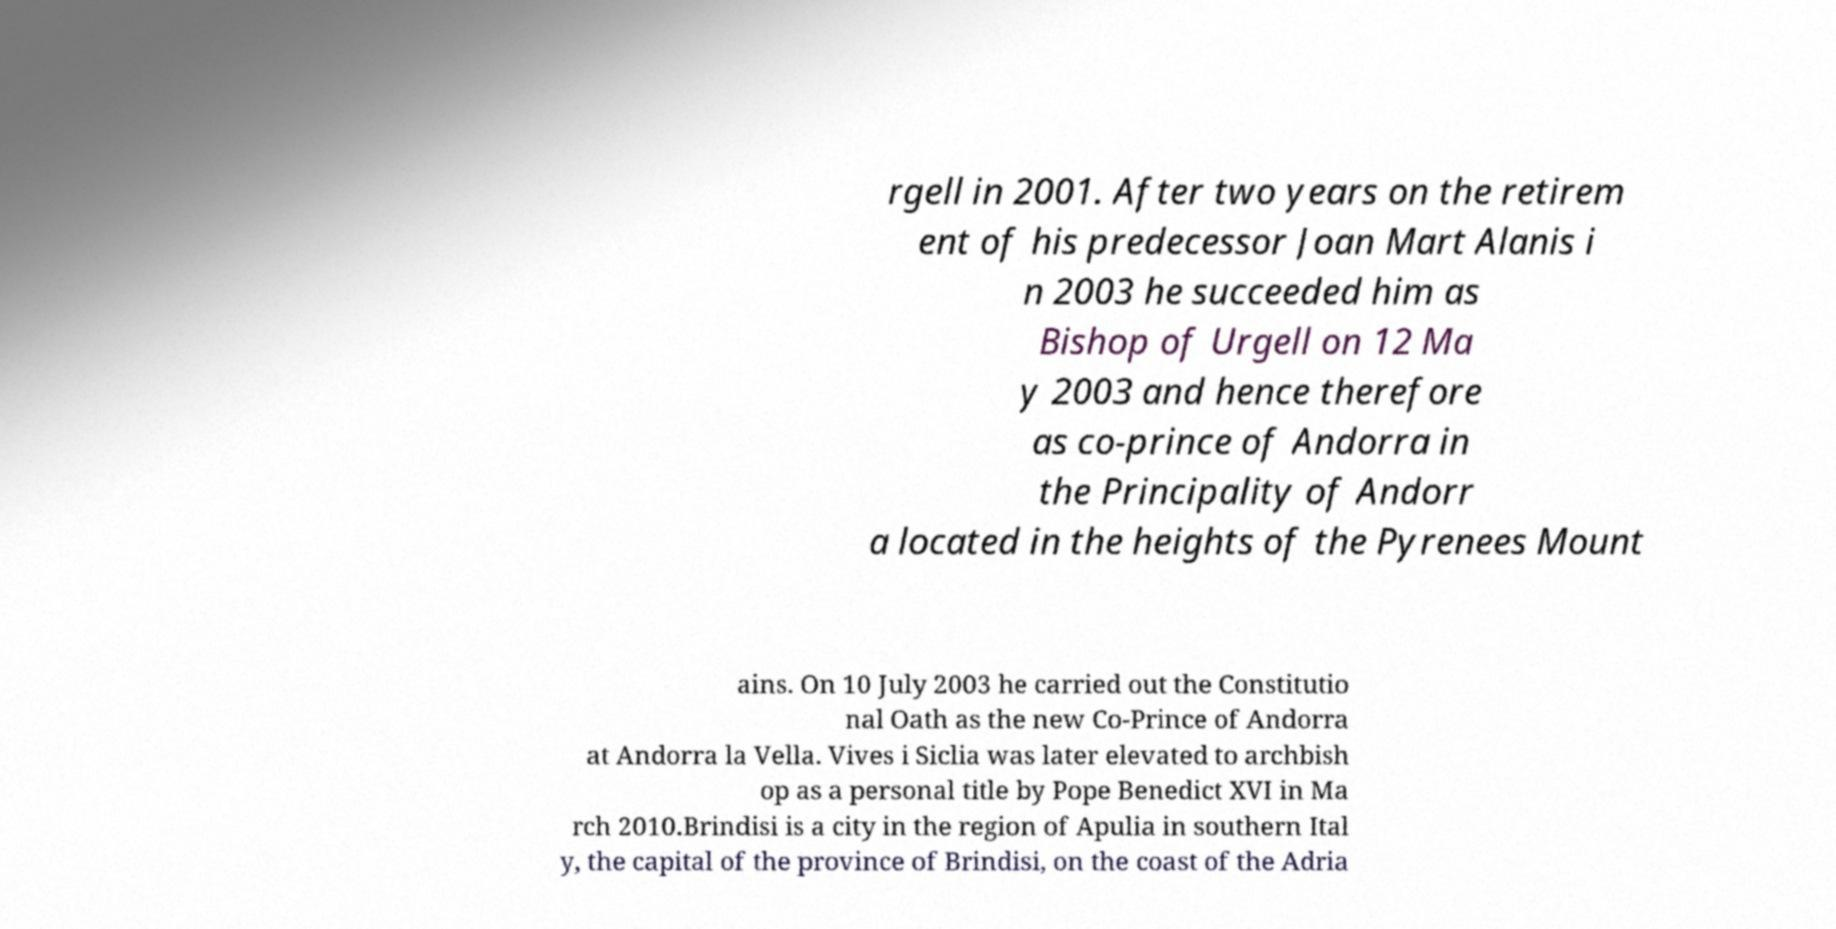What messages or text are displayed in this image? I need them in a readable, typed format. rgell in 2001. After two years on the retirem ent of his predecessor Joan Mart Alanis i n 2003 he succeeded him as Bishop of Urgell on 12 Ma y 2003 and hence therefore as co-prince of Andorra in the Principality of Andorr a located in the heights of the Pyrenees Mount ains. On 10 July 2003 he carried out the Constitutio nal Oath as the new Co-Prince of Andorra at Andorra la Vella. Vives i Siclia was later elevated to archbish op as a personal title by Pope Benedict XVI in Ma rch 2010.Brindisi is a city in the region of Apulia in southern Ital y, the capital of the province of Brindisi, on the coast of the Adria 